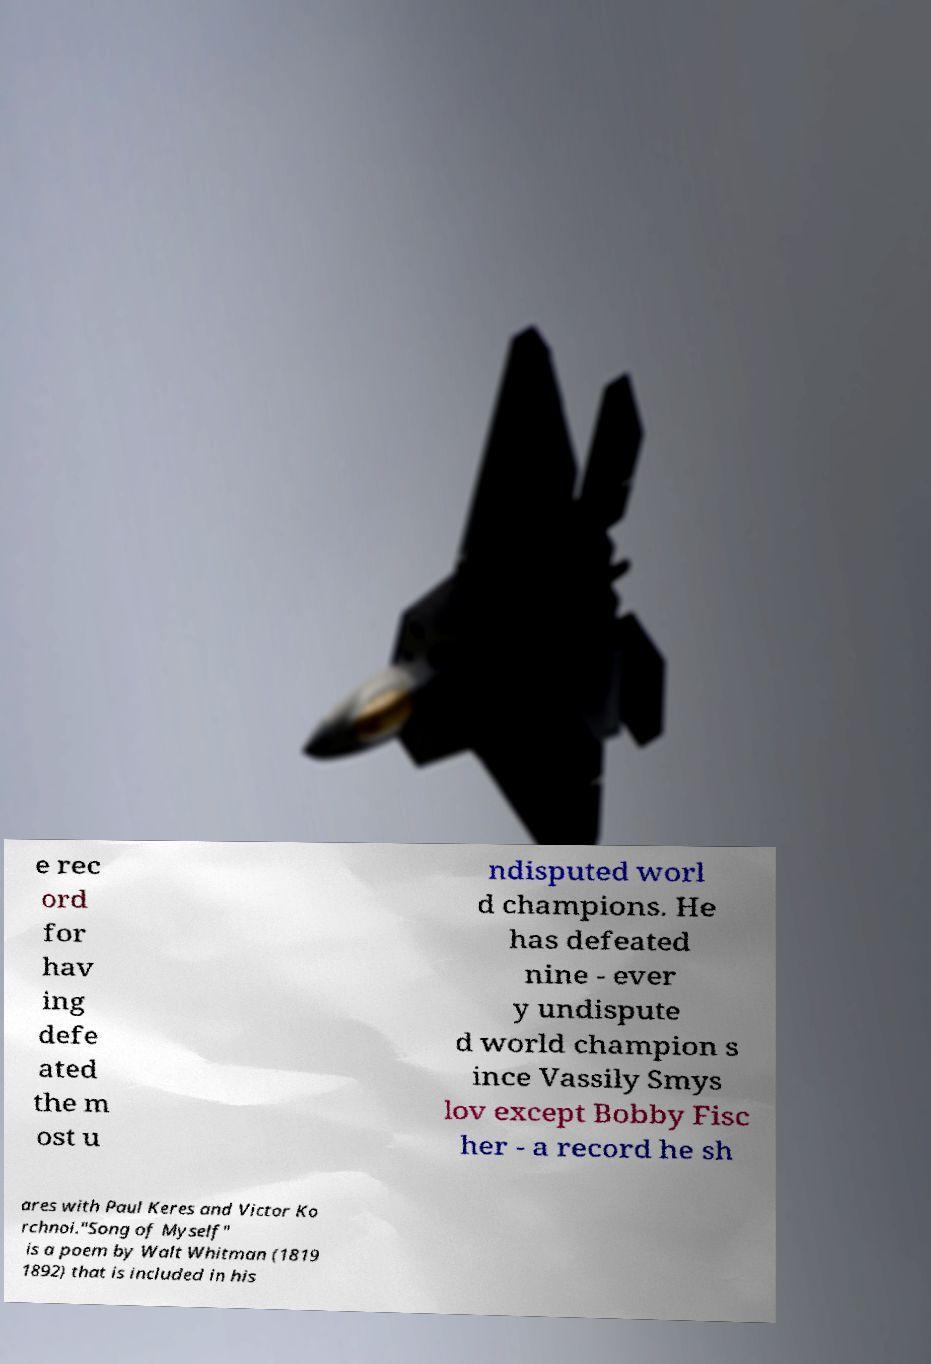For documentation purposes, I need the text within this image transcribed. Could you provide that? e rec ord for hav ing defe ated the m ost u ndisputed worl d champions. He has defeated nine - ever y undispute d world champion s ince Vassily Smys lov except Bobby Fisc her - a record he sh ares with Paul Keres and Victor Ko rchnoi."Song of Myself" is a poem by Walt Whitman (1819 1892) that is included in his 